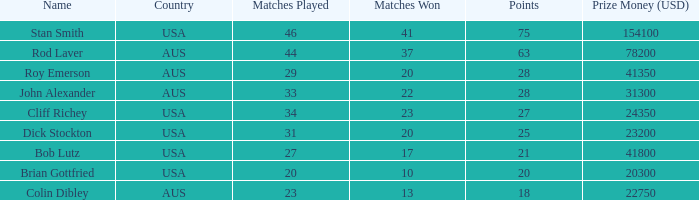What was the total count of matches won by colin dibley? 13.0. 